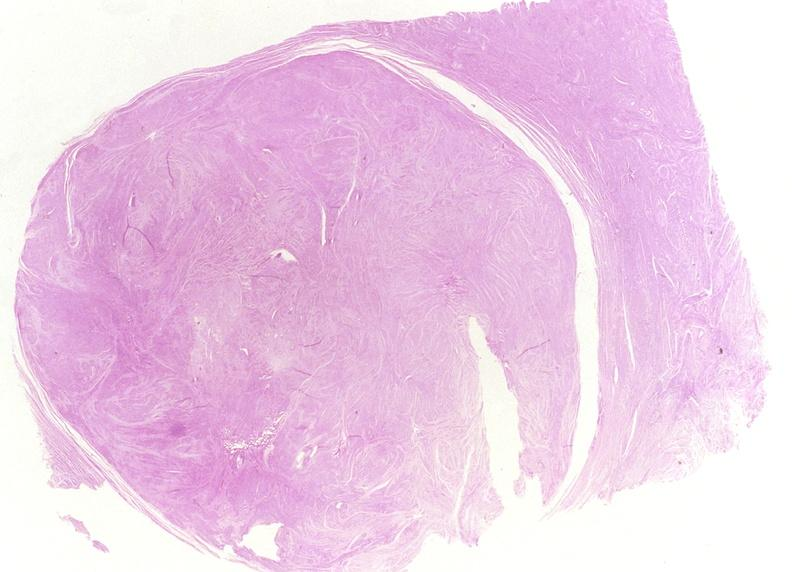does this partially fixed gross show leiomyoma?
Answer the question using a single word or phrase. No 